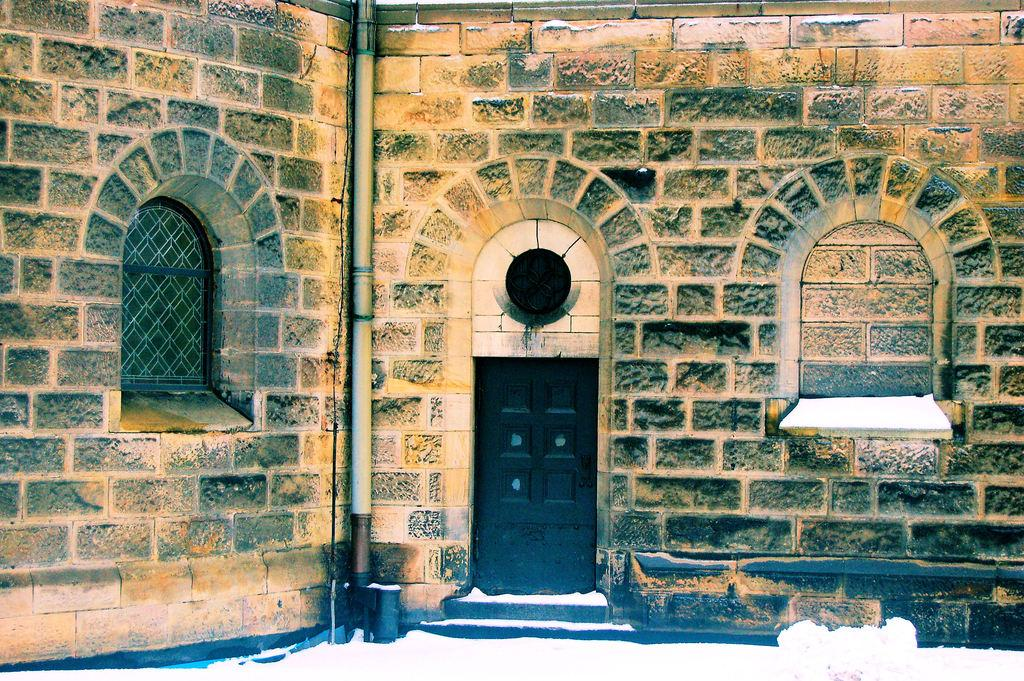What type of structure can be seen in the image? There is a wall in the image. Are there any openings in the wall? Yes, there are windows in the image. What else can be seen attached to the wall? There is a pole in the image. Is there a way to enter or exit the structure? Yes, there is a door in the image. What is the weather like in the image? Snow is visible in the image. What type of steel card do the brothers use to open the door in the image? There are no brothers or steel cards present in the image. 